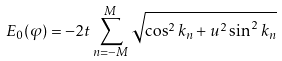Convert formula to latex. <formula><loc_0><loc_0><loc_500><loc_500>E _ { 0 } ( \varphi ) = - 2 t \sum _ { n = - M } ^ { M } \sqrt { \cos ^ { 2 } k _ { n } + u ^ { 2 } \sin ^ { 2 } k _ { n } }</formula> 